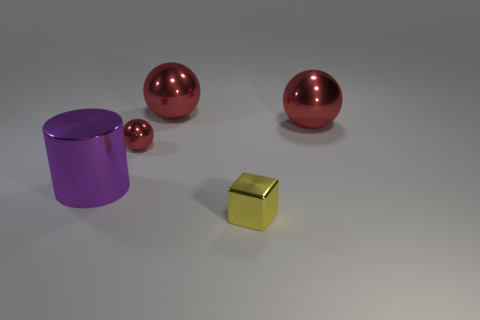Subtract all red balls. How many were subtracted if there are1red balls left? 2 Subtract all large red spheres. How many spheres are left? 1 Add 4 blue blocks. How many objects exist? 9 Subtract all blocks. How many objects are left? 4 Subtract 1 balls. How many balls are left? 2 Subtract all brown spheres. Subtract all blue blocks. How many spheres are left? 3 Add 5 big red objects. How many big red objects are left? 7 Add 2 shiny cylinders. How many shiny cylinders exist? 3 Subtract 0 brown blocks. How many objects are left? 5 Subtract all large cyan cubes. Subtract all cubes. How many objects are left? 4 